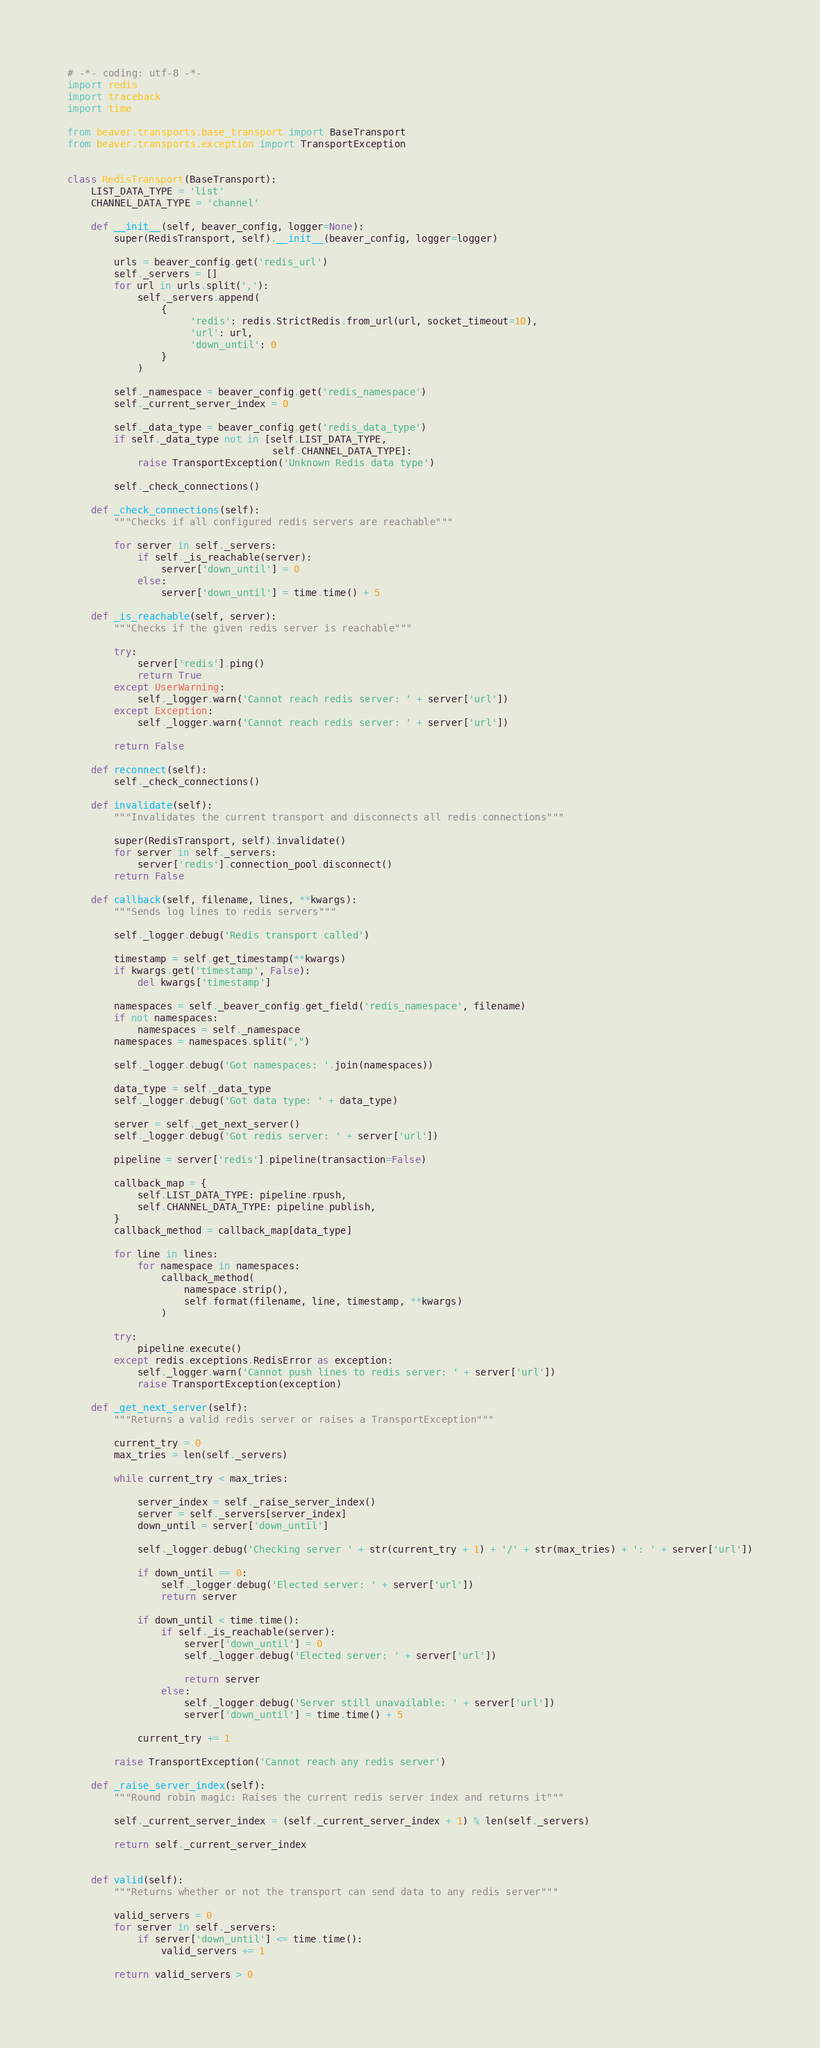<code> <loc_0><loc_0><loc_500><loc_500><_Python_># -*- coding: utf-8 -*-
import redis
import traceback
import time

from beaver.transports.base_transport import BaseTransport
from beaver.transports.exception import TransportException


class RedisTransport(BaseTransport):
    LIST_DATA_TYPE = 'list'
    CHANNEL_DATA_TYPE = 'channel'

    def __init__(self, beaver_config, logger=None):
        super(RedisTransport, self).__init__(beaver_config, logger=logger)

        urls = beaver_config.get('redis_url')
        self._servers = []
        for url in urls.split(','):
            self._servers.append(
                {
                     'redis': redis.StrictRedis.from_url(url, socket_timeout=10),
                     'url': url,
                     'down_until': 0
                }
            )

        self._namespace = beaver_config.get('redis_namespace')
        self._current_server_index = 0

        self._data_type = beaver_config.get('redis_data_type')
        if self._data_type not in [self.LIST_DATA_TYPE,
                                   self.CHANNEL_DATA_TYPE]:
            raise TransportException('Unknown Redis data type')

        self._check_connections()

    def _check_connections(self):
        """Checks if all configured redis servers are reachable"""

        for server in self._servers:
            if self._is_reachable(server):
                server['down_until'] = 0
            else:
                server['down_until'] = time.time() + 5

    def _is_reachable(self, server):
        """Checks if the given redis server is reachable"""

        try:
            server['redis'].ping()
            return True
        except UserWarning:
            self._logger.warn('Cannot reach redis server: ' + server['url'])
        except Exception:
            self._logger.warn('Cannot reach redis server: ' + server['url'])

        return False

    def reconnect(self):
        self._check_connections()

    def invalidate(self):
        """Invalidates the current transport and disconnects all redis connections"""

        super(RedisTransport, self).invalidate()
        for server in self._servers:
            server['redis'].connection_pool.disconnect()
        return False

    def callback(self, filename, lines, **kwargs):
        """Sends log lines to redis servers"""

        self._logger.debug('Redis transport called')

        timestamp = self.get_timestamp(**kwargs)
        if kwargs.get('timestamp', False):
            del kwargs['timestamp']

        namespaces = self._beaver_config.get_field('redis_namespace', filename)
        if not namespaces:
            namespaces = self._namespace
        namespaces = namespaces.split(",")

        self._logger.debug('Got namespaces: '.join(namespaces))

        data_type = self._data_type
        self._logger.debug('Got data type: ' + data_type)

        server = self._get_next_server()
        self._logger.debug('Got redis server: ' + server['url'])

        pipeline = server['redis'].pipeline(transaction=False)

        callback_map = {
            self.LIST_DATA_TYPE: pipeline.rpush,
            self.CHANNEL_DATA_TYPE: pipeline.publish,
        }
        callback_method = callback_map[data_type]

        for line in lines:
            for namespace in namespaces:
                callback_method(
                    namespace.strip(),
                    self.format(filename, line, timestamp, **kwargs)
                )

        try:
            pipeline.execute()
        except redis.exceptions.RedisError as exception:
            self._logger.warn('Cannot push lines to redis server: ' + server['url'])
            raise TransportException(exception)

    def _get_next_server(self):
        """Returns a valid redis server or raises a TransportException"""

        current_try = 0
        max_tries = len(self._servers)

        while current_try < max_tries:

            server_index = self._raise_server_index()
            server = self._servers[server_index]
            down_until = server['down_until']

            self._logger.debug('Checking server ' + str(current_try + 1) + '/' + str(max_tries) + ': ' + server['url'])

            if down_until == 0:
                self._logger.debug('Elected server: ' + server['url'])
                return server

            if down_until < time.time():
                if self._is_reachable(server):
                    server['down_until'] = 0
                    self._logger.debug('Elected server: ' + server['url'])

                    return server
                else:
                    self._logger.debug('Server still unavailable: ' + server['url'])
                    server['down_until'] = time.time() + 5

            current_try += 1

        raise TransportException('Cannot reach any redis server')

    def _raise_server_index(self):
        """Round robin magic: Raises the current redis server index and returns it"""

        self._current_server_index = (self._current_server_index + 1) % len(self._servers)

        return self._current_server_index


    def valid(self):
        """Returns whether or not the transport can send data to any redis server"""

        valid_servers = 0
        for server in self._servers:
            if server['down_until'] <= time.time():
                valid_servers += 1

        return valid_servers > 0
</code> 